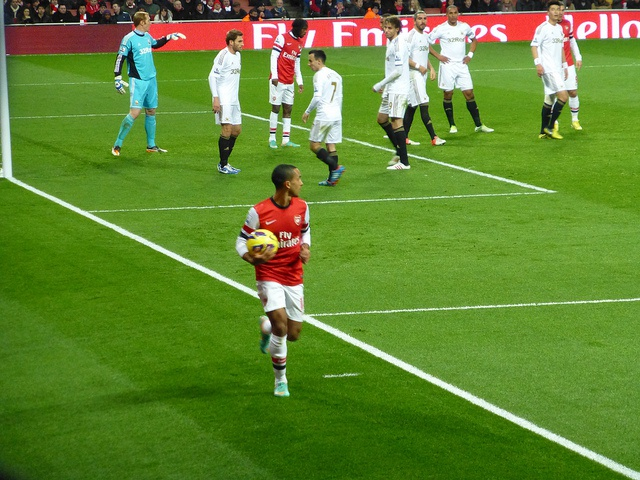Describe the objects in this image and their specific colors. I can see people in teal, white, brown, maroon, and black tones, people in teal, turquoise, black, and ivory tones, people in teal, white, black, darkgray, and tan tones, people in teal, white, black, olive, and gray tones, and people in teal, white, black, tan, and darkgreen tones in this image. 